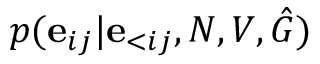<formula> <loc_0><loc_0><loc_500><loc_500>p ( e _ { i j } | e _ { < i j } , N , V , \hat { G } )</formula> 